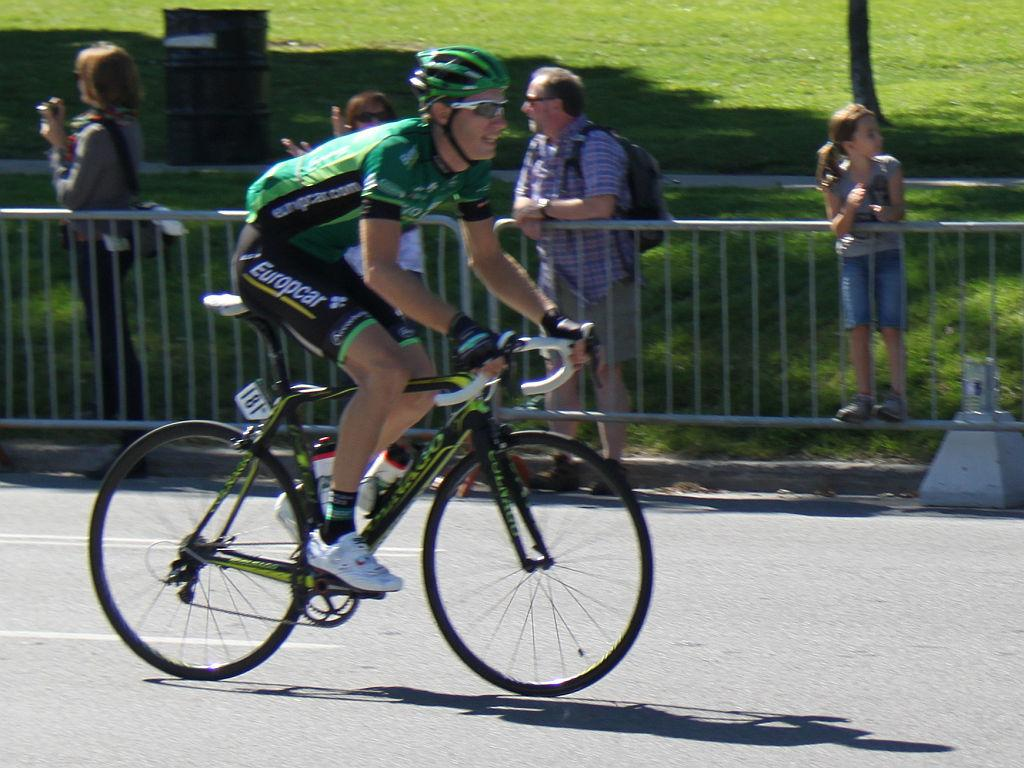What is the main subject of the image? There is a person riding a bicycle in the image. What are the other persons in the image doing? The other persons are watching the person riding the bicycle. How many legs can be seen on the tray in the image? There is no tray present in the image, so it is not possible to determine the number of legs on a tray. 